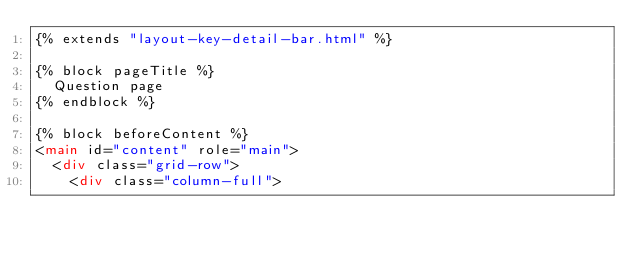Convert code to text. <code><loc_0><loc_0><loc_500><loc_500><_HTML_>{% extends "layout-key-detail-bar.html" %}

{% block pageTitle %}
  Question page
{% endblock %}

{% block beforeContent %}
<main id="content" role="main">
  <div class="grid-row">
    <div class="column-full">
</code> 